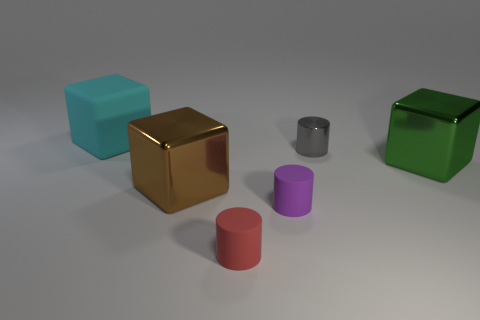If these objects had to be used in a simple machine, what could each represent? Intriguing thought! The large cubes could serve as stable bases or weights, the silver cylinder might work as a roller or shaft, and the smaller cylinders could act as movable pistons or connectors within such a machine. 